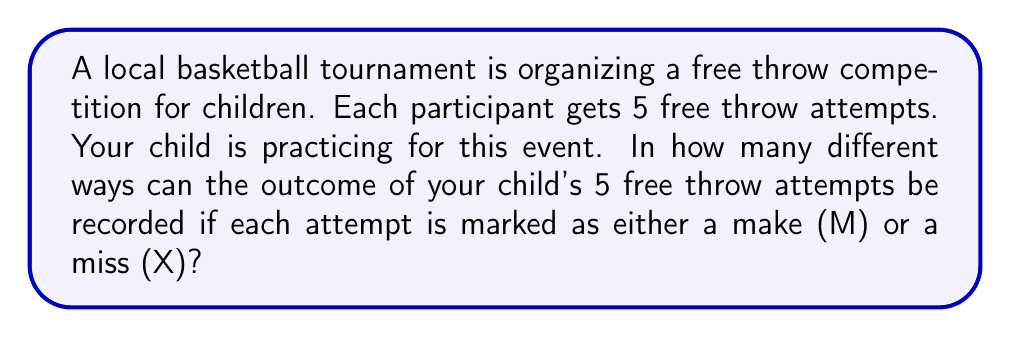What is the answer to this math problem? Let's approach this step-by-step:

1) For each free throw attempt, there are two possible outcomes: Make (M) or Miss (X).

2) We need to determine the number of possible outcomes for a series of 5 independent attempts.

3) This scenario can be modeled as a sequence of 5 independent events, each with 2 possible outcomes.

4) In combinatorics, this is an example of the multiplication principle.

5) The total number of possible outcomes is calculated by multiplying the number of possibilities for each event:

   $$ 2 \times 2 \times 2 \times 2 \times 2 = 2^5 $$

6) We can also think of this as creating a 5-digit string where each digit can be one of two values (M or X). This is equivalent to the number of ways to fill 5 positions, each with 2 choices.

7) Therefore, the total number of possible outcomes is:

   $$ 2^5 = 32 $$

This means there are 32 different possible sequences of makes and misses for the 5 free throw attempts.
Answer: $32$ 